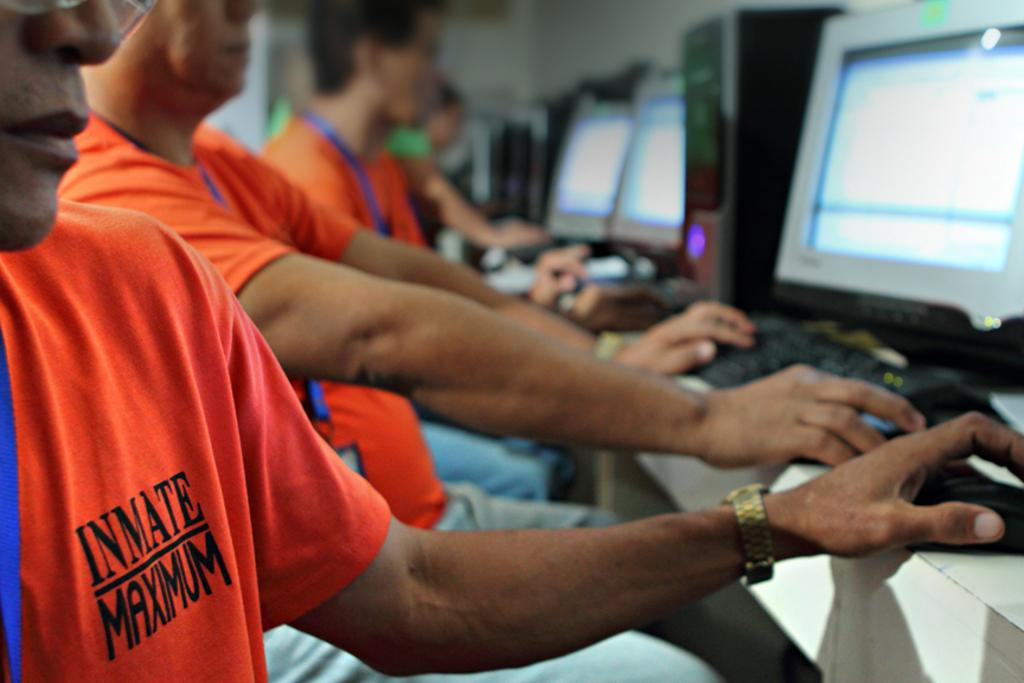Provide a one-sentence caption for the provided image. The person has clothing on it that says Inmate Maximum. 